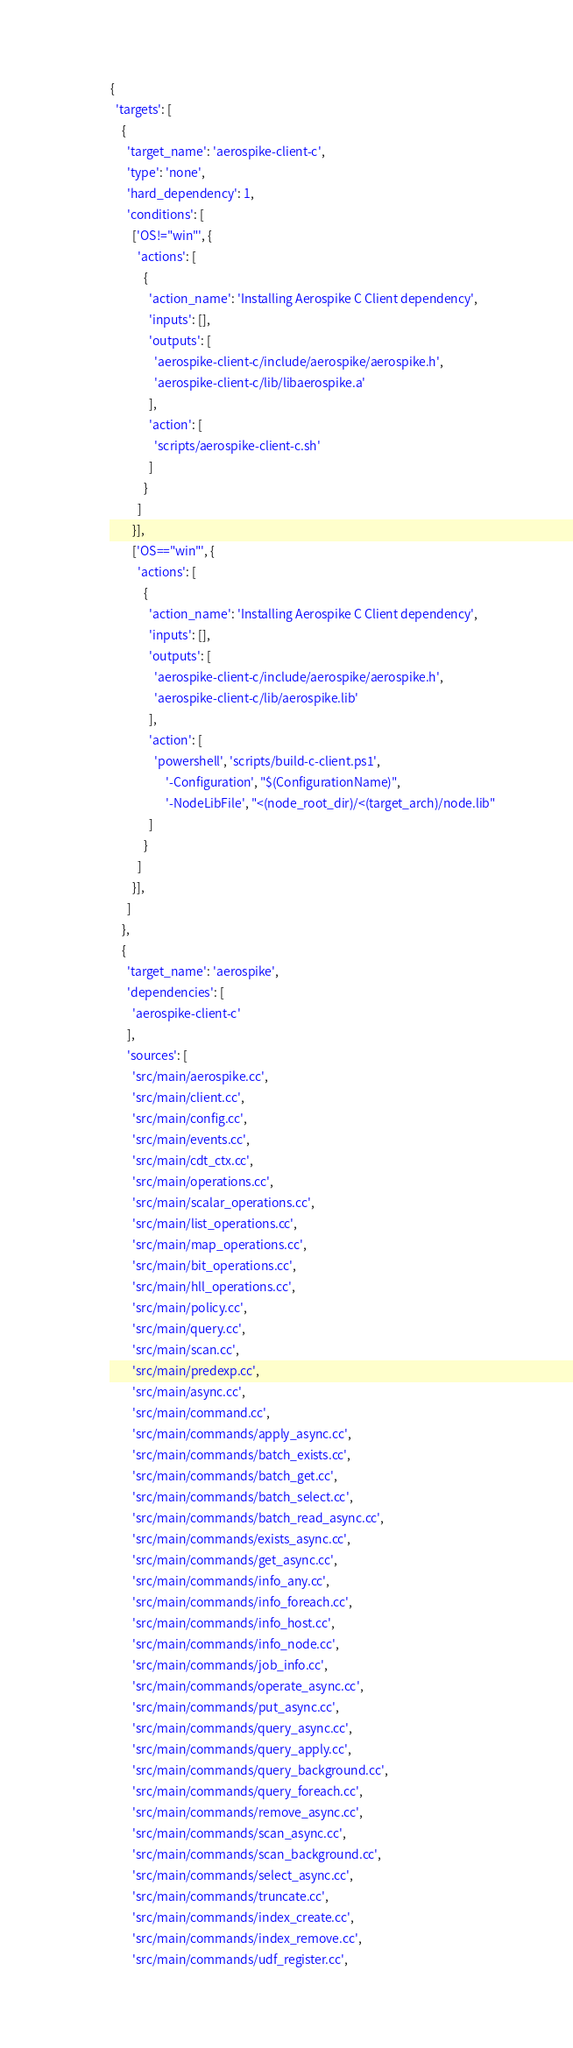Convert code to text. <code><loc_0><loc_0><loc_500><loc_500><_Python_>{
  'targets': [
    {
      'target_name': 'aerospike-client-c',
      'type': 'none',
      'hard_dependency': 1,
      'conditions': [
        ['OS!="win"', {
          'actions': [
            {
              'action_name': 'Installing Aerospike C Client dependency',
              'inputs': [],
              'outputs': [
                'aerospike-client-c/include/aerospike/aerospike.h',
                'aerospike-client-c/lib/libaerospike.a'
              ],
              'action': [
                'scripts/aerospike-client-c.sh'
              ]
            }
          ]
        }],
        ['OS=="win"', {
          'actions': [
            {
              'action_name': 'Installing Aerospike C Client dependency',
              'inputs': [],
              'outputs': [
                'aerospike-client-c/include/aerospike/aerospike.h',
                'aerospike-client-c/lib/aerospike.lib'
              ],
              'action': [
                'powershell', 'scripts/build-c-client.ps1',
                    '-Configuration', "$(ConfigurationName)",
                    '-NodeLibFile', "<(node_root_dir)/<(target_arch)/node.lib"
              ]
            }
          ]
        }],
      ]
    },
    {
      'target_name': 'aerospike',
      'dependencies': [
        'aerospike-client-c'
      ],
      'sources': [
        'src/main/aerospike.cc',
        'src/main/client.cc',
        'src/main/config.cc',
        'src/main/events.cc',
        'src/main/cdt_ctx.cc',
        'src/main/operations.cc',
        'src/main/scalar_operations.cc',
        'src/main/list_operations.cc',
        'src/main/map_operations.cc',
        'src/main/bit_operations.cc',
        'src/main/hll_operations.cc',
        'src/main/policy.cc',
        'src/main/query.cc',
        'src/main/scan.cc',
        'src/main/predexp.cc',
        'src/main/async.cc',
        'src/main/command.cc',
        'src/main/commands/apply_async.cc',
        'src/main/commands/batch_exists.cc',
        'src/main/commands/batch_get.cc',
        'src/main/commands/batch_select.cc',
        'src/main/commands/batch_read_async.cc',
        'src/main/commands/exists_async.cc',
        'src/main/commands/get_async.cc',
        'src/main/commands/info_any.cc',
        'src/main/commands/info_foreach.cc',
        'src/main/commands/info_host.cc',
        'src/main/commands/info_node.cc',
        'src/main/commands/job_info.cc',
        'src/main/commands/operate_async.cc',
        'src/main/commands/put_async.cc',
        'src/main/commands/query_async.cc',
        'src/main/commands/query_apply.cc',
        'src/main/commands/query_background.cc',
        'src/main/commands/query_foreach.cc',
        'src/main/commands/remove_async.cc',
        'src/main/commands/scan_async.cc',
        'src/main/commands/scan_background.cc',
        'src/main/commands/select_async.cc',
        'src/main/commands/truncate.cc',
        'src/main/commands/index_create.cc',
        'src/main/commands/index_remove.cc',
        'src/main/commands/udf_register.cc',</code> 